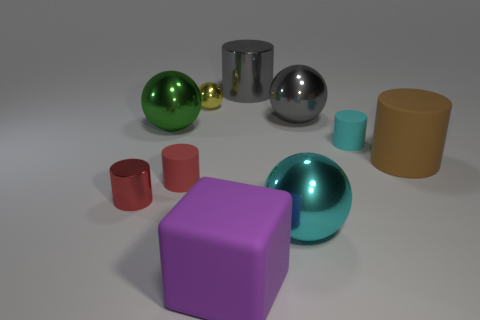What is the size of the sphere that is behind the gray object on the right side of the cyan shiny ball?
Keep it short and to the point. Small. What number of other tiny cylinders have the same color as the small shiny cylinder?
Provide a short and direct response. 1. What number of tiny shiny cylinders are there?
Your answer should be compact. 1. What number of brown cylinders are made of the same material as the big purple thing?
Ensure brevity in your answer.  1. There is a cyan object that is the same shape as the green metallic thing; what size is it?
Make the answer very short. Large. What is the cyan cylinder made of?
Make the answer very short. Rubber. What is the big cylinder that is in front of the cyan matte thing that is right of the large metallic sphere that is on the right side of the cyan metal thing made of?
Give a very brief answer. Rubber. Is there anything else that is the same shape as the tiny cyan rubber object?
Provide a short and direct response. Yes. What is the color of the other small object that is the same shape as the green metallic object?
Provide a short and direct response. Yellow. There is a big cylinder that is behind the tiny cyan rubber object; is its color the same as the small metallic thing to the right of the big green thing?
Provide a short and direct response. No. 